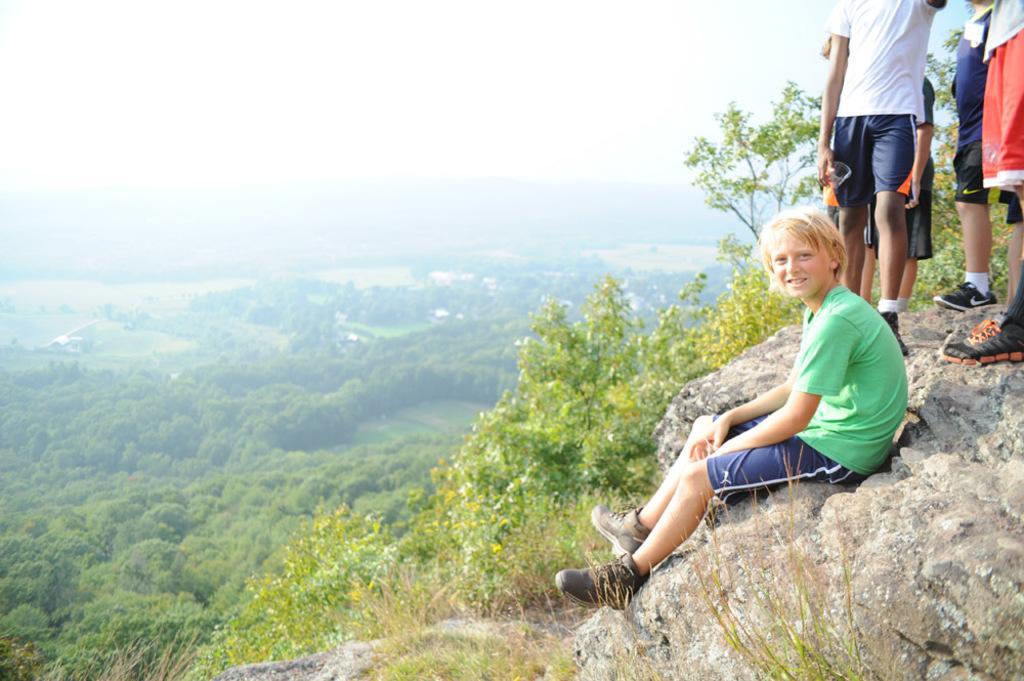How would you summarize this image in a sentence or two? In this image there is a boy sitting on the top of the mountain and few are standing, in the background there are trees. 